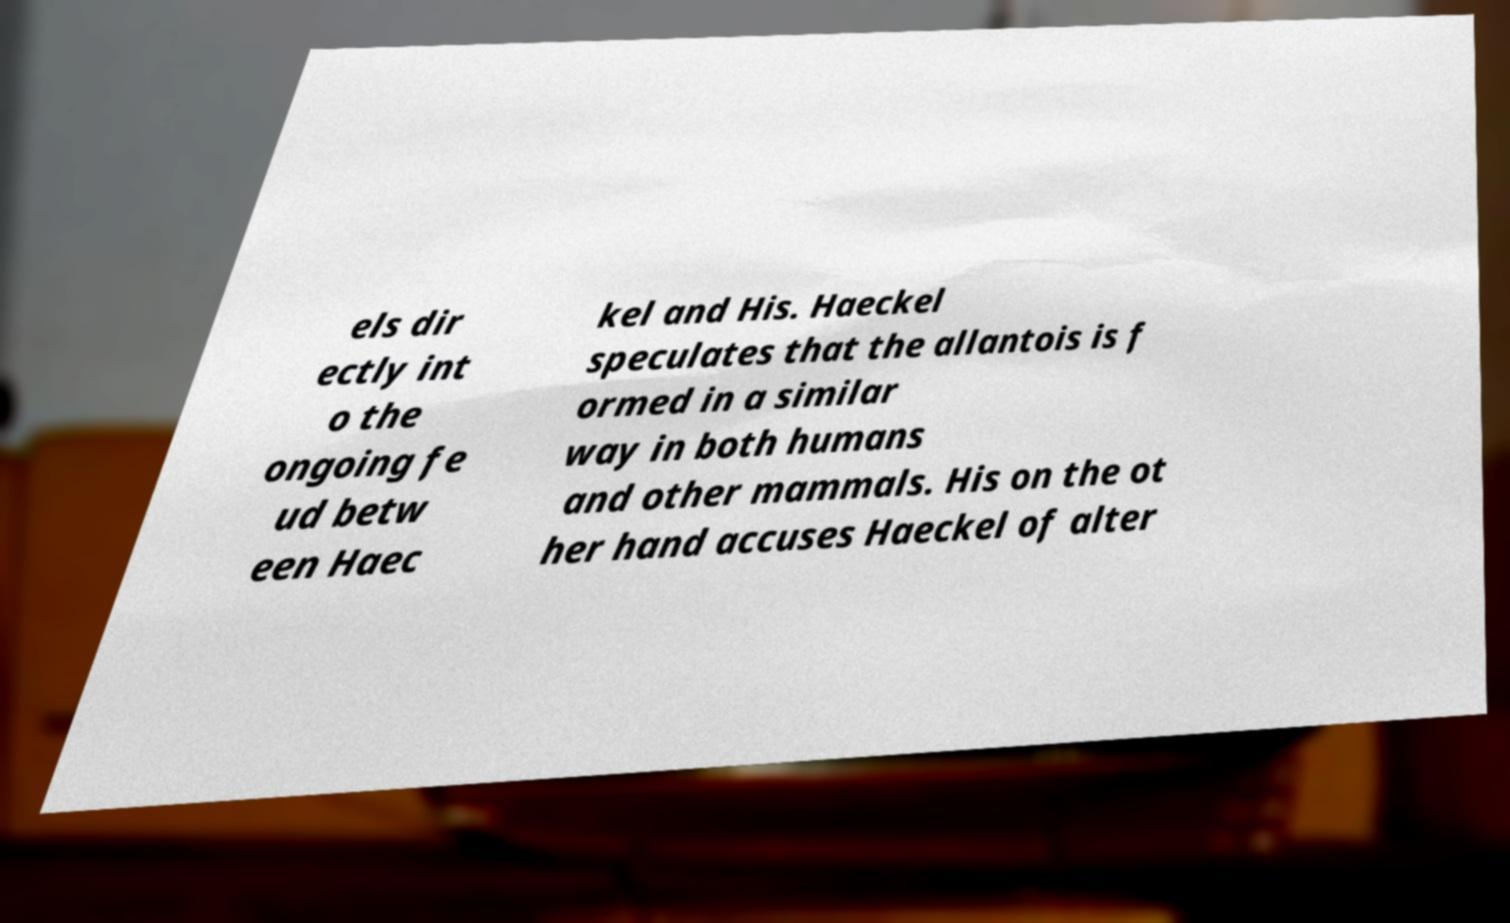Please read and relay the text visible in this image. What does it say? els dir ectly int o the ongoing fe ud betw een Haec kel and His. Haeckel speculates that the allantois is f ormed in a similar way in both humans and other mammals. His on the ot her hand accuses Haeckel of alter 